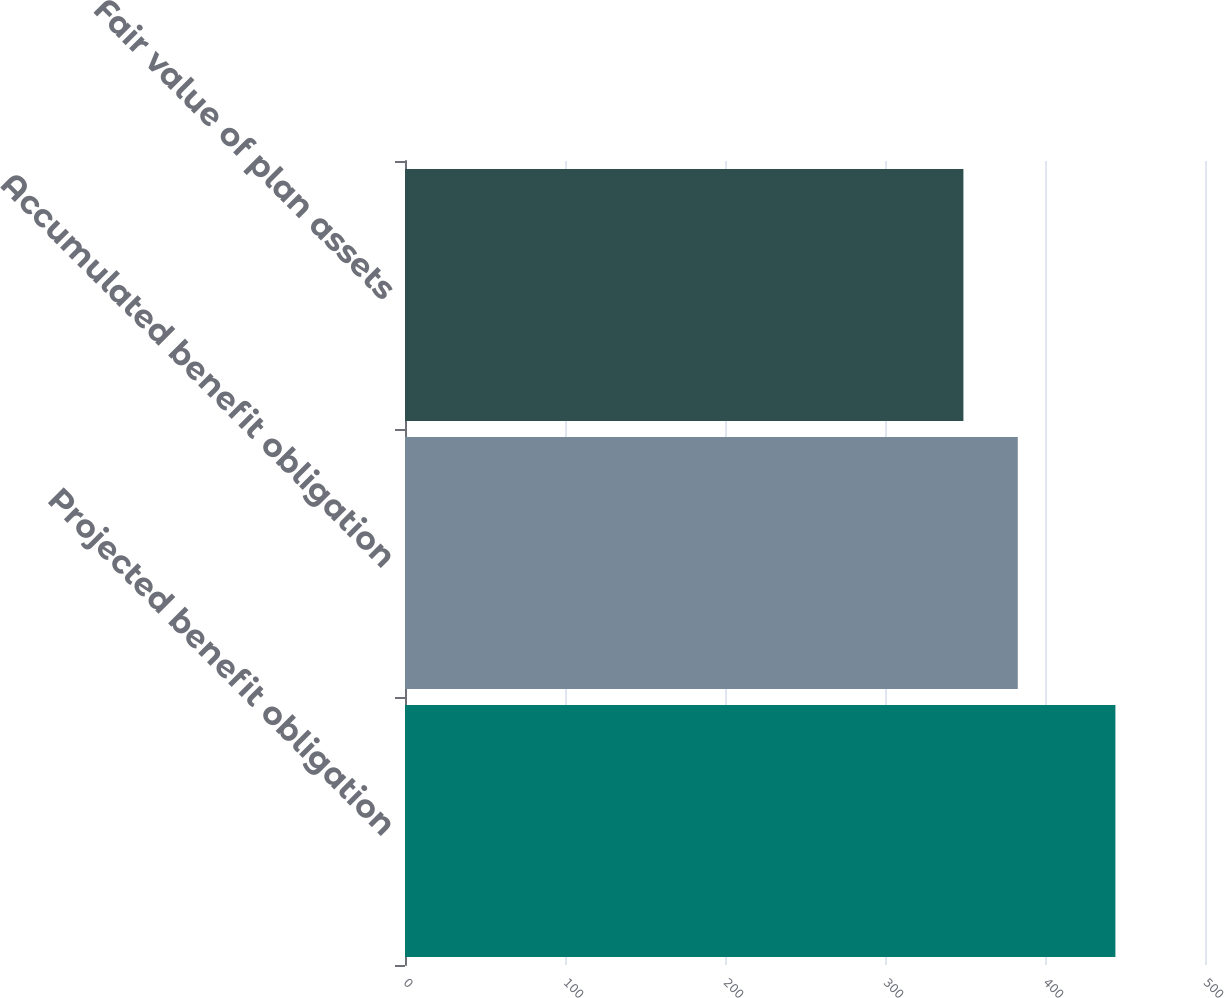<chart> <loc_0><loc_0><loc_500><loc_500><bar_chart><fcel>Projected benefit obligation<fcel>Accumulated benefit obligation<fcel>Fair value of plan assets<nl><fcel>444<fcel>383<fcel>349<nl></chart> 